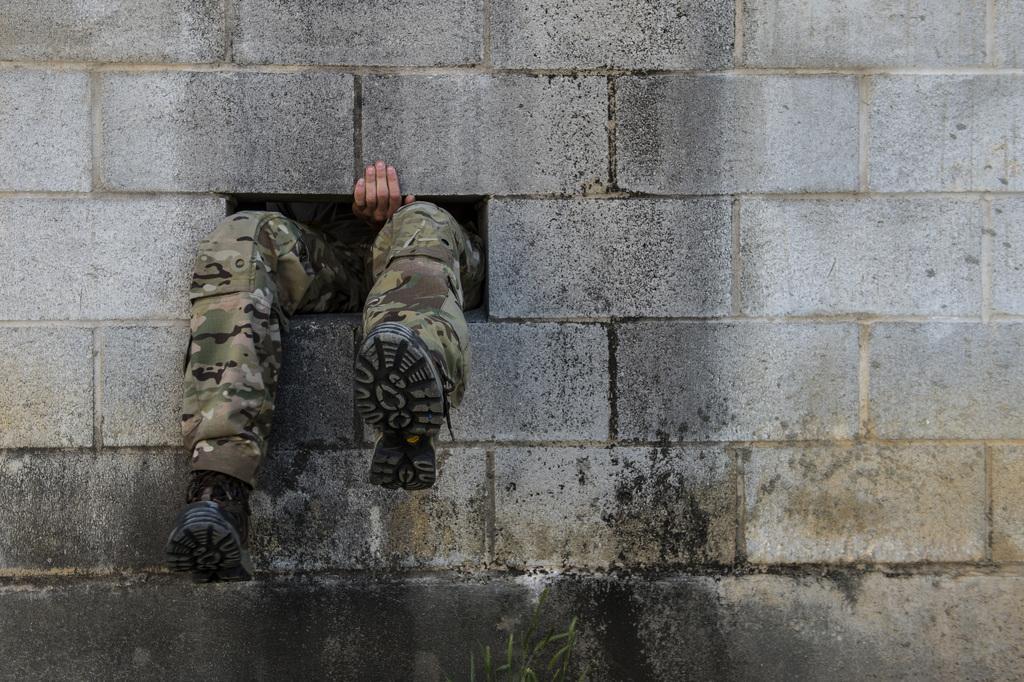How would you summarize this image in a sentence or two? In the image we can see there are legs of a person, the person is wearing shoes and there is a hand of a person. The wall is made up of bricks. 